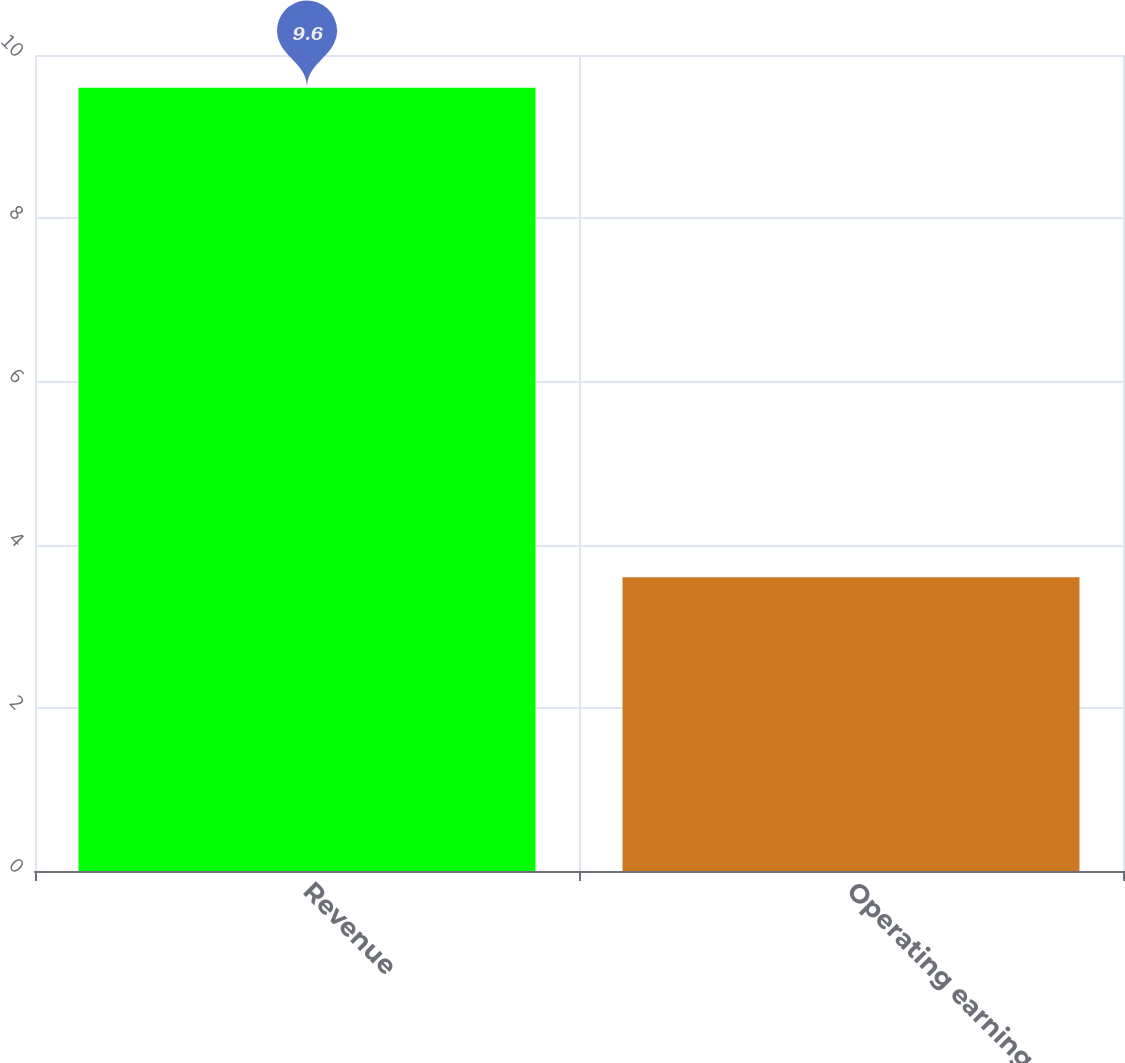<chart> <loc_0><loc_0><loc_500><loc_500><bar_chart><fcel>Revenue<fcel>Operating earnings<nl><fcel>9.6<fcel>3.6<nl></chart> 